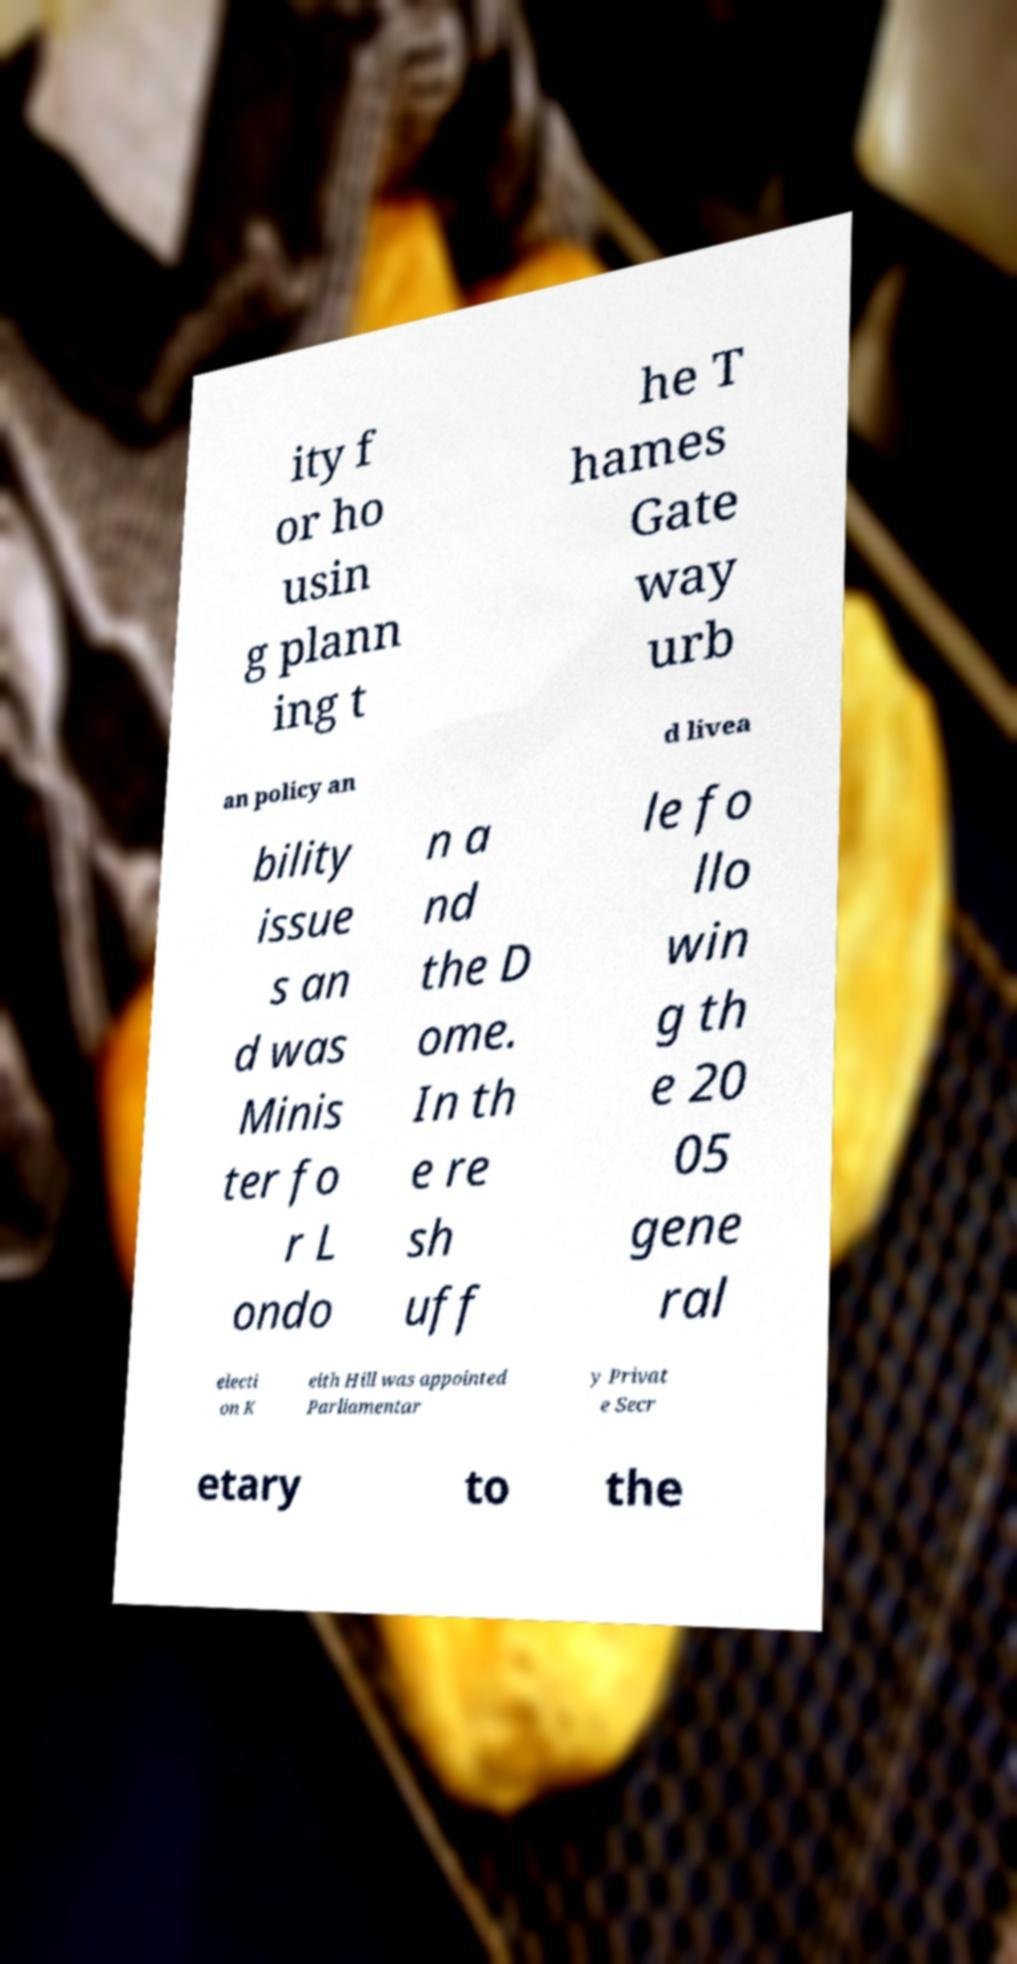There's text embedded in this image that I need extracted. Can you transcribe it verbatim? ity f or ho usin g plann ing t he T hames Gate way urb an policy an d livea bility issue s an d was Minis ter fo r L ondo n a nd the D ome. In th e re sh uff le fo llo win g th e 20 05 gene ral electi on K eith Hill was appointed Parliamentar y Privat e Secr etary to the 